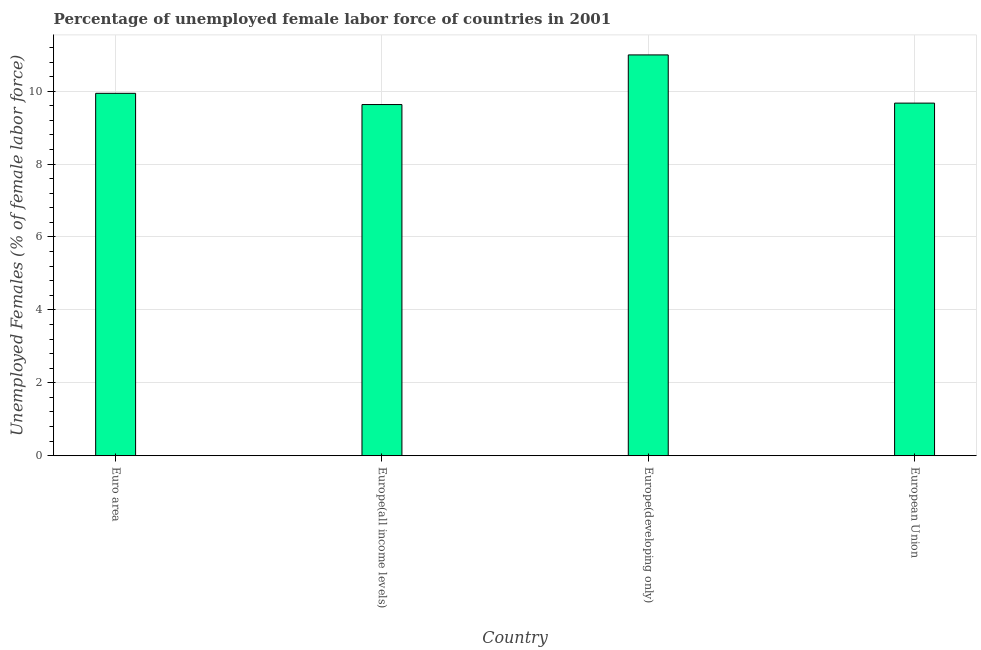Does the graph contain any zero values?
Give a very brief answer. No. Does the graph contain grids?
Make the answer very short. Yes. What is the title of the graph?
Offer a terse response. Percentage of unemployed female labor force of countries in 2001. What is the label or title of the Y-axis?
Ensure brevity in your answer.  Unemployed Females (% of female labor force). What is the total unemployed female labour force in European Union?
Your answer should be compact. 9.67. Across all countries, what is the maximum total unemployed female labour force?
Make the answer very short. 10.99. Across all countries, what is the minimum total unemployed female labour force?
Offer a terse response. 9.63. In which country was the total unemployed female labour force maximum?
Ensure brevity in your answer.  Europe(developing only). In which country was the total unemployed female labour force minimum?
Ensure brevity in your answer.  Europe(all income levels). What is the sum of the total unemployed female labour force?
Your answer should be compact. 40.24. What is the difference between the total unemployed female labour force in Europe(all income levels) and European Union?
Offer a terse response. -0.04. What is the average total unemployed female labour force per country?
Your answer should be compact. 10.06. What is the median total unemployed female labour force?
Offer a very short reply. 9.81. What is the ratio of the total unemployed female labour force in Euro area to that in Europe(developing only)?
Give a very brief answer. 0.9. Is the total unemployed female labour force in Europe(all income levels) less than that in Europe(developing only)?
Offer a terse response. Yes. Is the difference between the total unemployed female labour force in Euro area and European Union greater than the difference between any two countries?
Make the answer very short. No. What is the difference between the highest and the second highest total unemployed female labour force?
Make the answer very short. 1.05. What is the difference between the highest and the lowest total unemployed female labour force?
Offer a terse response. 1.36. In how many countries, is the total unemployed female labour force greater than the average total unemployed female labour force taken over all countries?
Offer a terse response. 1. How many bars are there?
Provide a succinct answer. 4. What is the difference between two consecutive major ticks on the Y-axis?
Provide a short and direct response. 2. Are the values on the major ticks of Y-axis written in scientific E-notation?
Your answer should be very brief. No. What is the Unemployed Females (% of female labor force) of Euro area?
Make the answer very short. 9.94. What is the Unemployed Females (% of female labor force) in Europe(all income levels)?
Your answer should be very brief. 9.63. What is the Unemployed Females (% of female labor force) of Europe(developing only)?
Ensure brevity in your answer.  10.99. What is the Unemployed Females (% of female labor force) in European Union?
Provide a succinct answer. 9.67. What is the difference between the Unemployed Females (% of female labor force) in Euro area and Europe(all income levels)?
Offer a terse response. 0.31. What is the difference between the Unemployed Females (% of female labor force) in Euro area and Europe(developing only)?
Give a very brief answer. -1.05. What is the difference between the Unemployed Females (% of female labor force) in Euro area and European Union?
Ensure brevity in your answer.  0.27. What is the difference between the Unemployed Females (% of female labor force) in Europe(all income levels) and Europe(developing only)?
Provide a short and direct response. -1.36. What is the difference between the Unemployed Females (% of female labor force) in Europe(all income levels) and European Union?
Your response must be concise. -0.04. What is the difference between the Unemployed Females (% of female labor force) in Europe(developing only) and European Union?
Ensure brevity in your answer.  1.32. What is the ratio of the Unemployed Females (% of female labor force) in Euro area to that in Europe(all income levels)?
Give a very brief answer. 1.03. What is the ratio of the Unemployed Females (% of female labor force) in Euro area to that in Europe(developing only)?
Make the answer very short. 0.9. What is the ratio of the Unemployed Females (% of female labor force) in Euro area to that in European Union?
Your answer should be compact. 1.03. What is the ratio of the Unemployed Females (% of female labor force) in Europe(all income levels) to that in Europe(developing only)?
Your response must be concise. 0.88. What is the ratio of the Unemployed Females (% of female labor force) in Europe(developing only) to that in European Union?
Offer a very short reply. 1.14. 